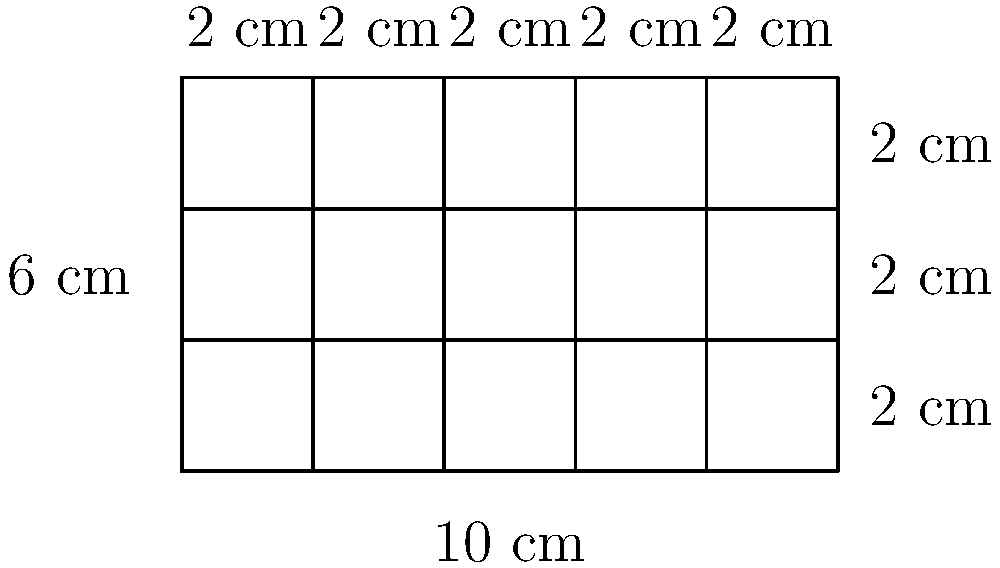In your research on the influence of names on personal identity, you're creating a family tree diagram to visualize generational name patterns. The rectangular diagram is divided into 15 equal-sized cells, representing different family members. If the overall dimensions of the diagram are 10 cm by 6 cm, what is the area of each individual cell in square centimeters? To find the area of each individual cell, we need to follow these steps:

1. Calculate the total area of the rectangular diagram:
   Area = length × width
   $A = 10 \text{ cm} \times 6 \text{ cm} = 60 \text{ cm}^2$

2. Count the number of cells in the diagram:
   There are 5 columns and 3 rows, so the total number of cells is:
   $5 \times 3 = 15 \text{ cells}$

3. Calculate the area of each individual cell:
   Area per cell = Total area ÷ Number of cells
   $A_{\text{cell}} = \frac{60 \text{ cm}^2}{15} = 4 \text{ cm}^2$

Therefore, each individual cell in the family tree diagram has an area of 4 square centimeters.
Answer: $4 \text{ cm}^2$ 